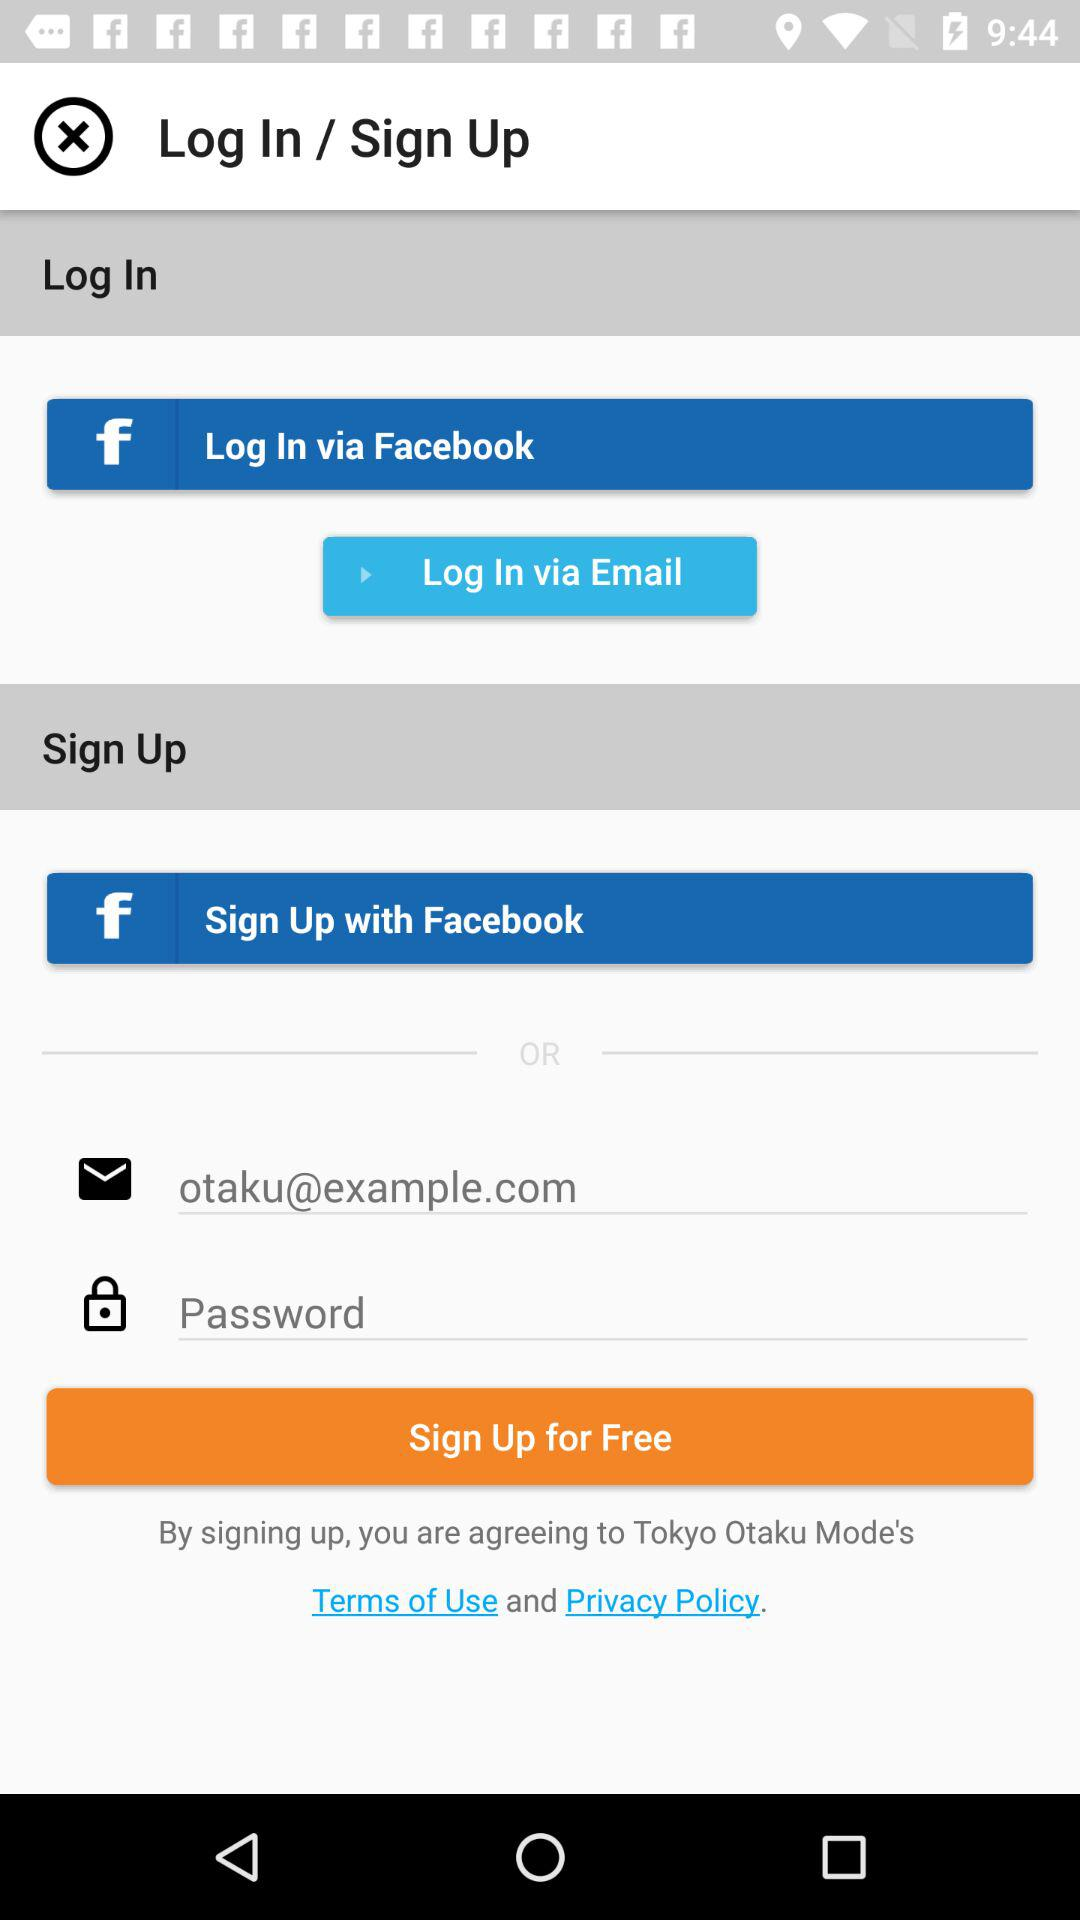How many more inputs are there for the sign up form than the log in form?
Answer the question using a single word or phrase. 2 